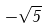Convert formula to latex. <formula><loc_0><loc_0><loc_500><loc_500>- \sqrt { 5 }</formula> 